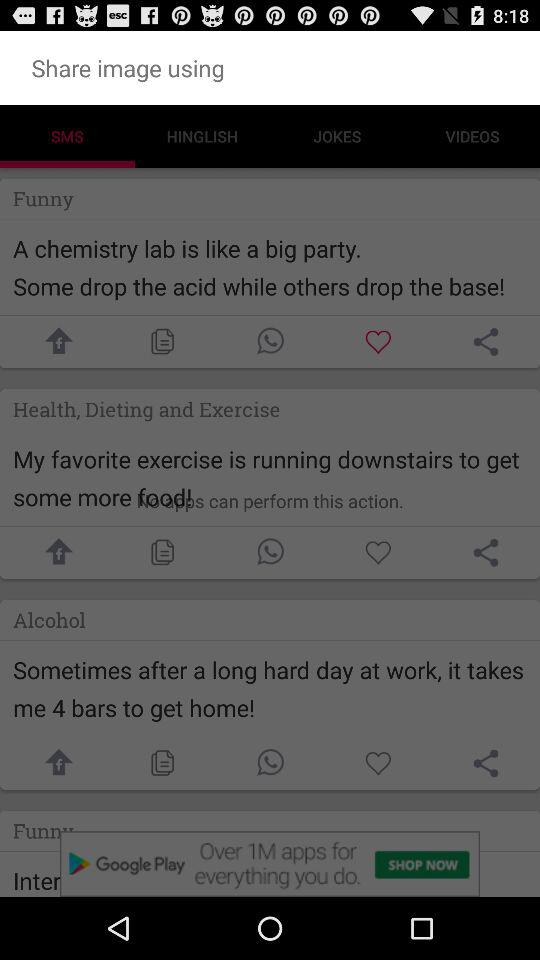Through which application can be share?
When the provided information is insufficient, respond with <no answer>. <no answer> 